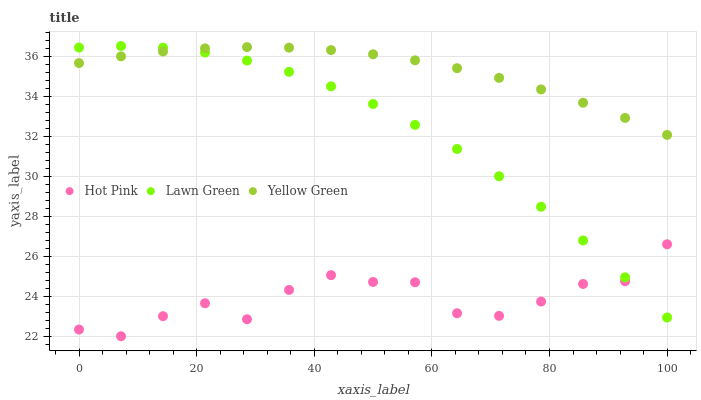Does Hot Pink have the minimum area under the curve?
Answer yes or no. Yes. Does Yellow Green have the maximum area under the curve?
Answer yes or no. Yes. Does Yellow Green have the minimum area under the curve?
Answer yes or no. No. Does Hot Pink have the maximum area under the curve?
Answer yes or no. No. Is Yellow Green the smoothest?
Answer yes or no. Yes. Is Hot Pink the roughest?
Answer yes or no. Yes. Is Hot Pink the smoothest?
Answer yes or no. No. Is Yellow Green the roughest?
Answer yes or no. No. Does Hot Pink have the lowest value?
Answer yes or no. Yes. Does Yellow Green have the lowest value?
Answer yes or no. No. Does Lawn Green have the highest value?
Answer yes or no. Yes. Does Yellow Green have the highest value?
Answer yes or no. No. Is Hot Pink less than Yellow Green?
Answer yes or no. Yes. Is Yellow Green greater than Hot Pink?
Answer yes or no. Yes. Does Yellow Green intersect Lawn Green?
Answer yes or no. Yes. Is Yellow Green less than Lawn Green?
Answer yes or no. No. Is Yellow Green greater than Lawn Green?
Answer yes or no. No. Does Hot Pink intersect Yellow Green?
Answer yes or no. No. 